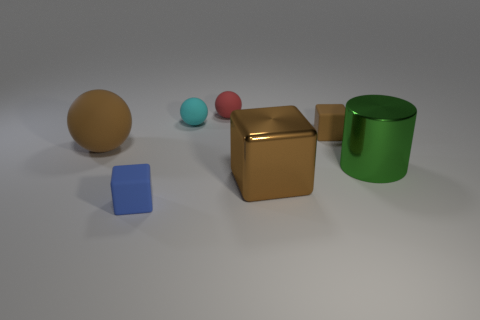Subtract all red spheres. How many brown blocks are left? 2 Subtract all brown cubes. How many cubes are left? 1 Add 2 blue matte blocks. How many objects exist? 9 Subtract all balls. How many objects are left? 4 Subtract 0 cyan cubes. How many objects are left? 7 Subtract all red objects. Subtract all brown metallic objects. How many objects are left? 5 Add 6 small objects. How many small objects are left? 10 Add 7 small brown blocks. How many small brown blocks exist? 8 